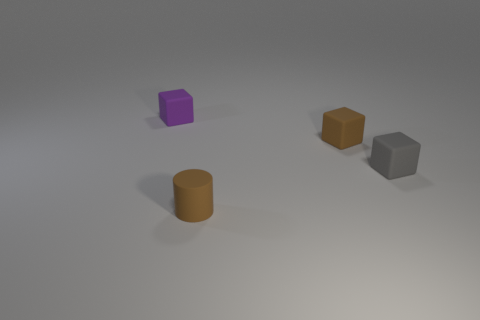Add 2 rubber blocks. How many objects exist? 6 Subtract all blocks. How many objects are left? 1 Subtract 0 red cubes. How many objects are left? 4 Subtract all large cylinders. Subtract all brown matte blocks. How many objects are left? 3 Add 1 gray objects. How many gray objects are left? 2 Add 1 small cylinders. How many small cylinders exist? 2 